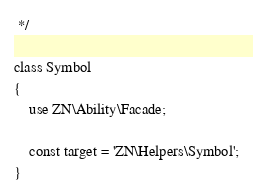<code> <loc_0><loc_0><loc_500><loc_500><_PHP_> */

class Symbol
{
    use ZN\Ability\Facade;

    const target = 'ZN\Helpers\Symbol';
}</code> 